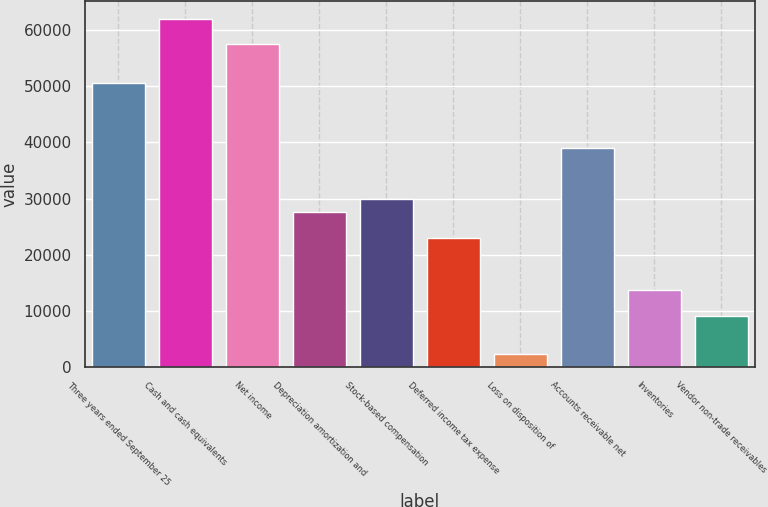<chart> <loc_0><loc_0><loc_500><loc_500><bar_chart><fcel>Three years ended September 25<fcel>Cash and cash equivalents<fcel>Net income<fcel>Depreciation amortization and<fcel>Stock-based compensation<fcel>Deferred income tax expense<fcel>Loss on disposition of<fcel>Accounts receivable net<fcel>Inventories<fcel>Vendor non-trade receivables<nl><fcel>50511<fcel>61988.5<fcel>57397.5<fcel>27556<fcel>29851.5<fcel>22965<fcel>2305.5<fcel>39033.5<fcel>13783<fcel>9192<nl></chart> 